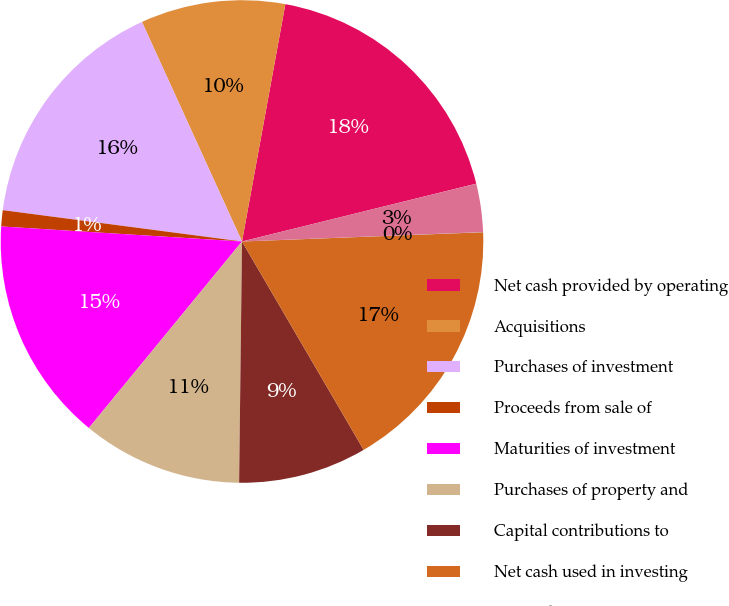Convert chart. <chart><loc_0><loc_0><loc_500><loc_500><pie_chart><fcel>Net cash provided by operating<fcel>Acquisitions<fcel>Purchases of investment<fcel>Proceeds from sale of<fcel>Maturities of investment<fcel>Purchases of property and<fcel>Capital contributions to<fcel>Net cash used in investing<fcel>Proceeds from issuance of<fcel>Change in book overdraft<nl><fcel>18.27%<fcel>9.68%<fcel>16.12%<fcel>1.08%<fcel>15.05%<fcel>10.75%<fcel>8.6%<fcel>17.2%<fcel>0.01%<fcel>3.23%<nl></chart> 